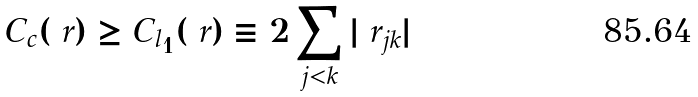<formula> <loc_0><loc_0><loc_500><loc_500>C _ { c } ( \ r ) \geq C _ { l _ { 1 } } ( \ r ) \equiv 2 \sum _ { j < k } | \ r _ { j k } |</formula> 